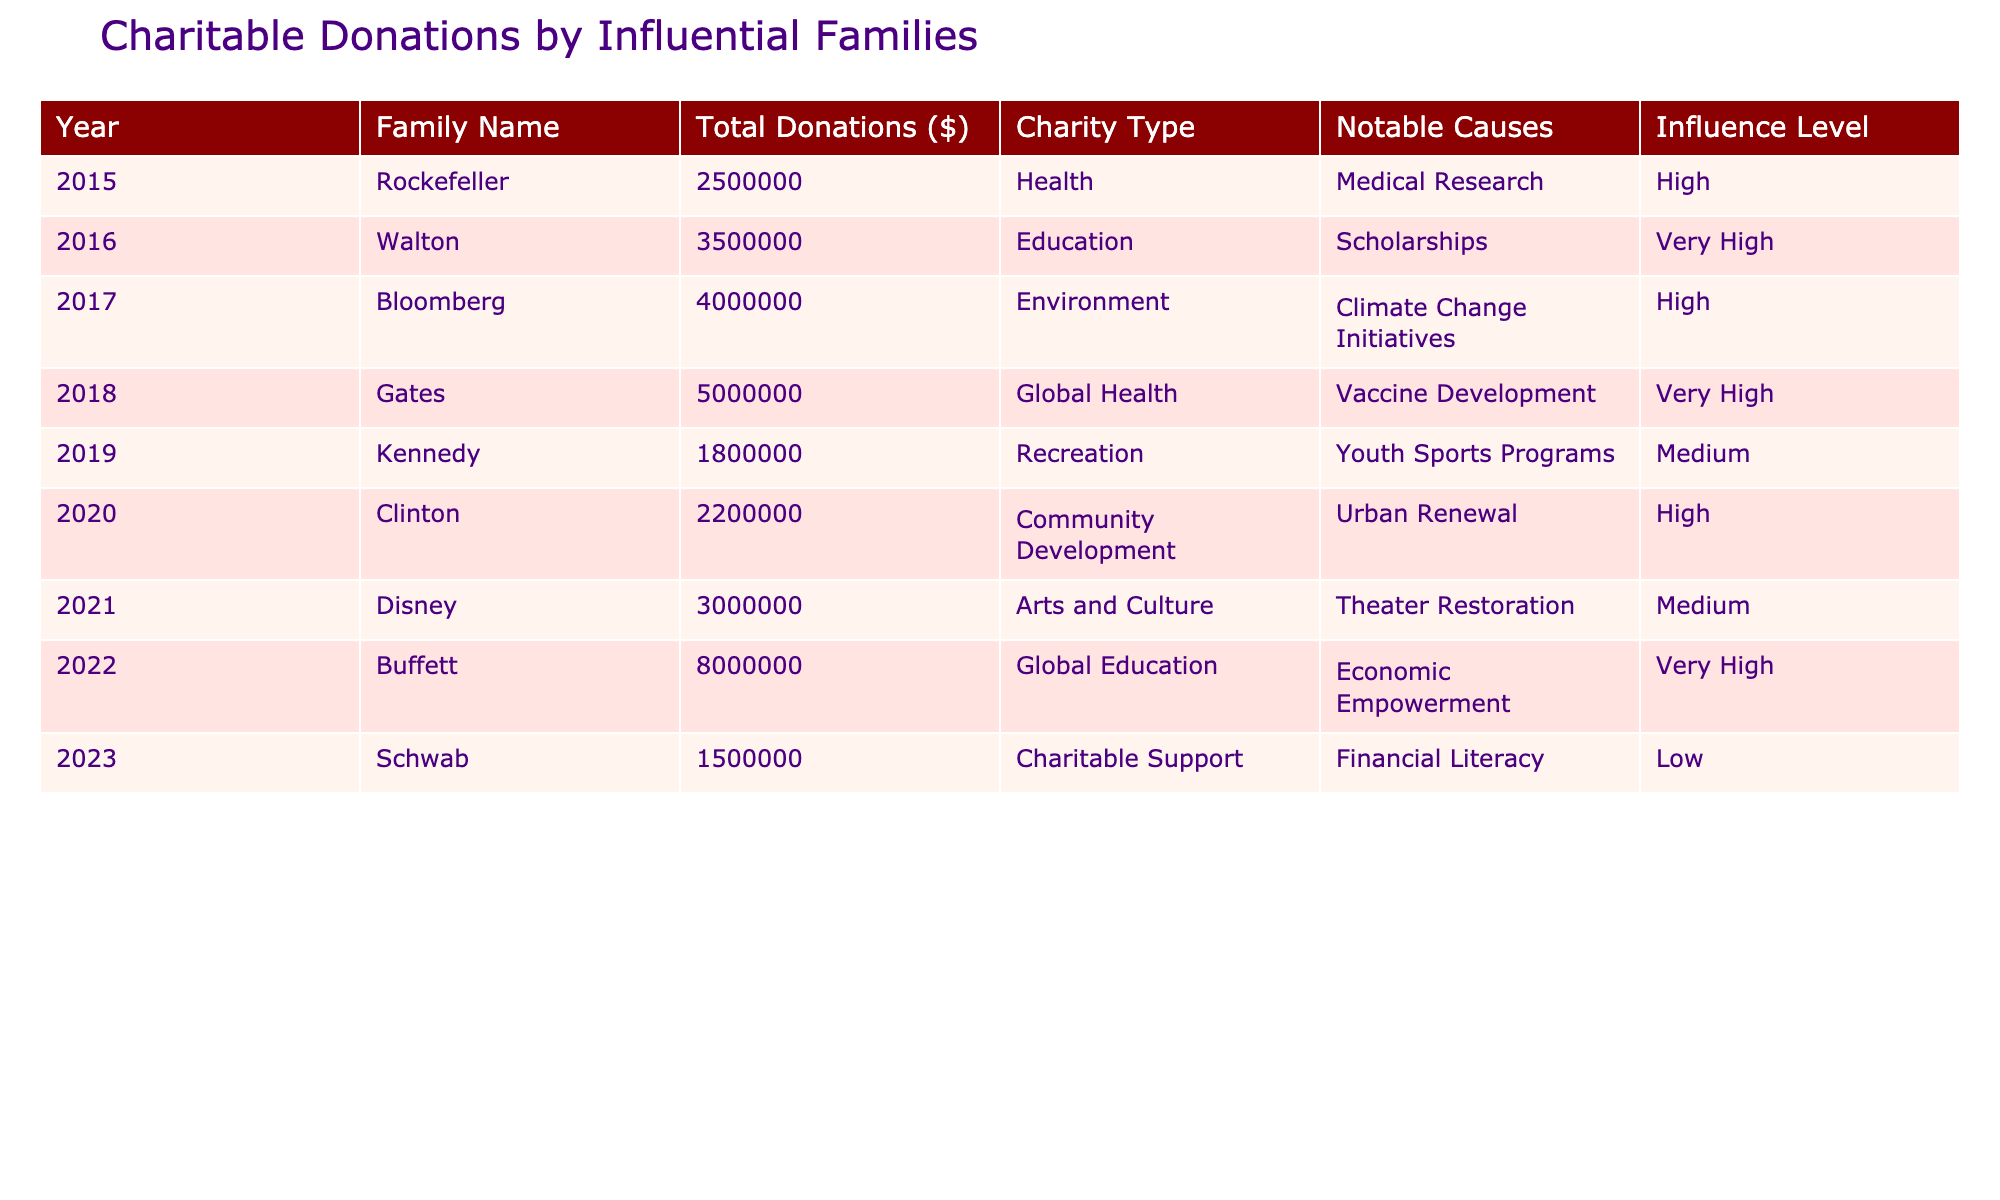What was the total amount donated by the Gates family in 2018? The table shows that the Gates family donated a total of $5,000,000 in 2018.
Answer: $5,000,000 Which charity received the highest total donations, and how much did they receive? According to the table, the Buffett family donated the highest total amount of $8,000,000 to Global Education in 2022.
Answer: Buffett family, $8,000,000 How many families made donations to the education sector? By examining the table, I see that the Walton family in 2016 and the Buffett family in 2022 made donations to the education sector. That's a total of 2 families.
Answer: 2 families What is the average donation amount among the families listed in the table? To find the average, first sum the total donations: $2,500,000 + $3,500,000 + $4,000,000 + $5,000,000 + $1,800,000 + $2,200,000 + $3,000,000 + $8,000,000 + $1,500,000 = $32,500,000. Then, divide by the number of families (9), giving us an average of $3,611,111.11.
Answer: $3,611,111.11 Did the Schwab family have a higher influence level than the Kennedy family? According to the table, the Schwab family's influence level is categorized as Low, while the Kennedy family's influence level is Medium. Therefore, Schnwab did not have a higher influence level.
Answer: No Which family had the lowest total donations, and what was the amount? The table indicates that the Schwab family made the lowest total donation of $1,500,000 in 2023.
Answer: Schwab family, $1,500,000 Which charity type received a donation from the Walton family? The data shows that the Walton family donated to the education sector in 2016.
Answer: Education How much more did the Gates family's donation surpass the Kennedy family's donation? The Gates family donated $5,000,000 while the Kennedy family donated $1,800,000. Subtracting these gives: $5,000,000 - $1,800,000 = $3,200,000. Therefore, Gates' donation surpassed Kennedy's by $3,200,000.
Answer: $3,200,000 How many families had an influence level categorized as "Very High"? Referring to the table, the families categorized as "Very High" influence level are the Walton family (2016), Gates family (2018), and Buffett family (2022), totaling 3 families.
Answer: 3 families 